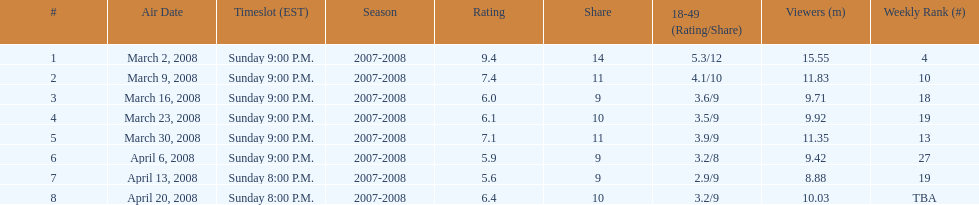During which time slot were the first 6 episodes of the show aired? Sunday 9:00 P.M. 